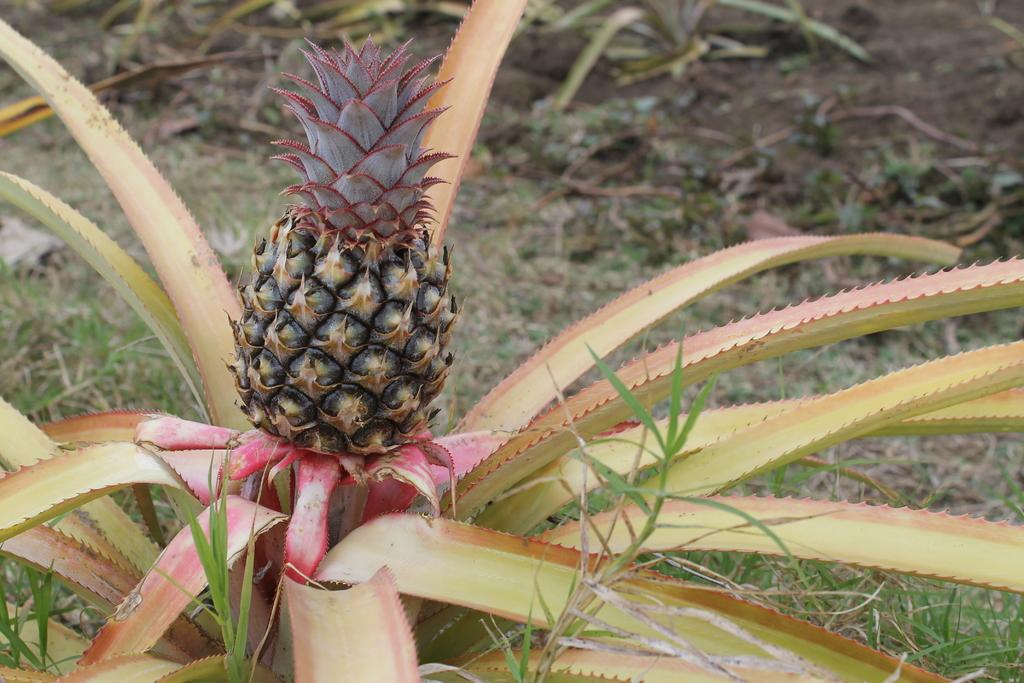What type of plant is in the image? There is a pineapple plant in the image. What is the pineapple plant producing? The pineapple plant has pineapples. Can you describe the background of the image? The background of the image is blurred. What type of vegetation is visible in the image? There is grass visible in the image. What type of silk is being used to read a book in the image? There is no silk or book present in the image; it features a pineapple plant with pineapples and a blurred background. Can you see a flame in the image? There is no flame present in the image. 